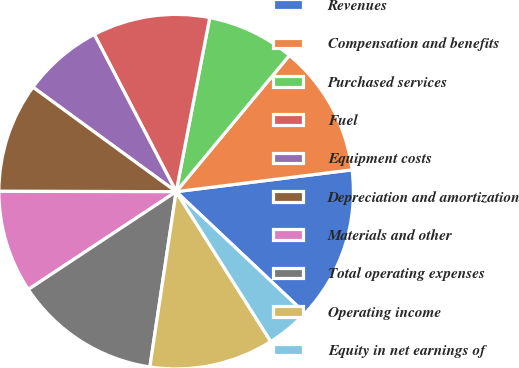Convert chart to OTSL. <chart><loc_0><loc_0><loc_500><loc_500><pie_chart><fcel>Revenues<fcel>Compensation and benefits<fcel>Purchased services<fcel>Fuel<fcel>Equipment costs<fcel>Depreciation and amortization<fcel>Materials and other<fcel>Total operating expenses<fcel>Operating income<fcel>Equity in net earnings of<nl><fcel>14.0%<fcel>12.0%<fcel>8.0%<fcel>10.67%<fcel>7.33%<fcel>10.0%<fcel>9.33%<fcel>13.33%<fcel>11.33%<fcel>4.0%<nl></chart> 